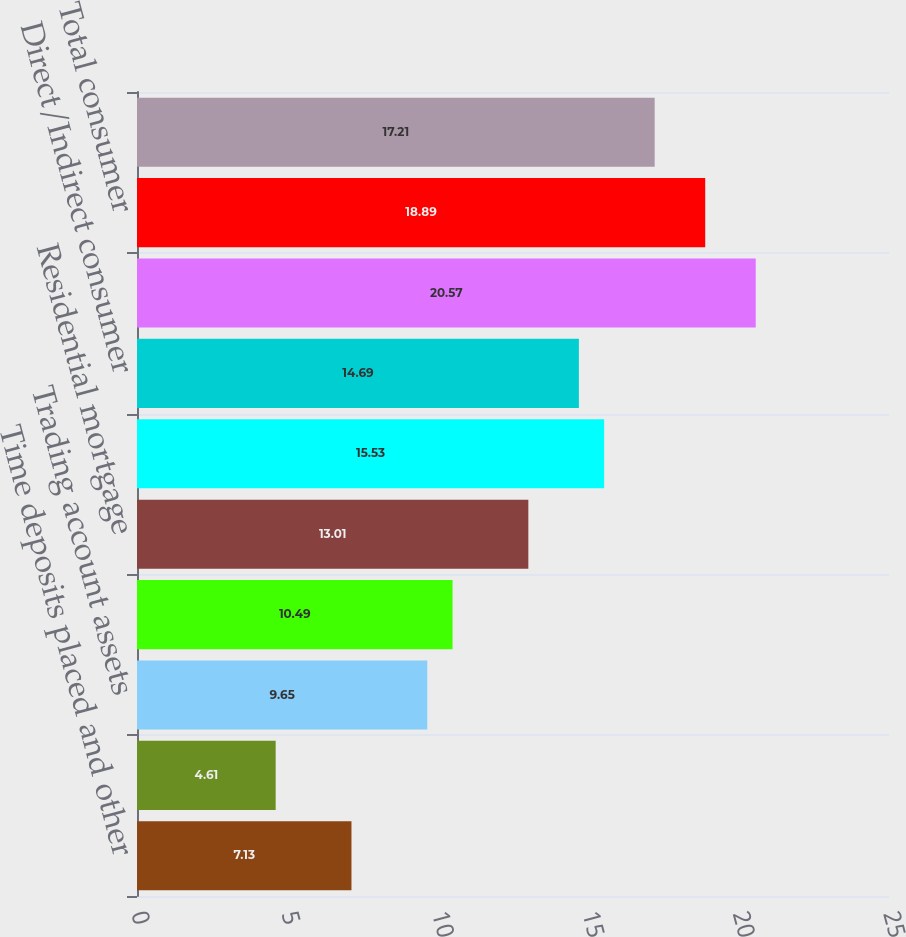<chart> <loc_0><loc_0><loc_500><loc_500><bar_chart><fcel>Time deposits placed and other<fcel>Federal funds sold and<fcel>Trading account assets<fcel>Securities<fcel>Residential mortgage<fcel>Homeequitylines<fcel>Direct/Indirect consumer<fcel>Other consumer (2)<fcel>Total consumer<fcel>Commercial-domestic<nl><fcel>7.13<fcel>4.61<fcel>9.65<fcel>10.49<fcel>13.01<fcel>15.53<fcel>14.69<fcel>20.57<fcel>18.89<fcel>17.21<nl></chart> 